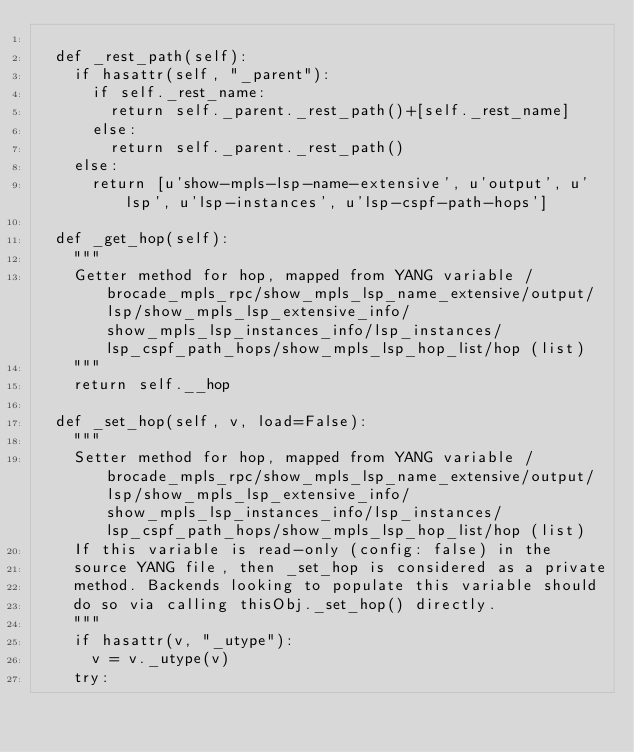<code> <loc_0><loc_0><loc_500><loc_500><_Python_>
  def _rest_path(self):
    if hasattr(self, "_parent"):
      if self._rest_name:
        return self._parent._rest_path()+[self._rest_name]
      else:
        return self._parent._rest_path()
    else:
      return [u'show-mpls-lsp-name-extensive', u'output', u'lsp', u'lsp-instances', u'lsp-cspf-path-hops']

  def _get_hop(self):
    """
    Getter method for hop, mapped from YANG variable /brocade_mpls_rpc/show_mpls_lsp_name_extensive/output/lsp/show_mpls_lsp_extensive_info/show_mpls_lsp_instances_info/lsp_instances/lsp_cspf_path_hops/show_mpls_lsp_hop_list/hop (list)
    """
    return self.__hop
      
  def _set_hop(self, v, load=False):
    """
    Setter method for hop, mapped from YANG variable /brocade_mpls_rpc/show_mpls_lsp_name_extensive/output/lsp/show_mpls_lsp_extensive_info/show_mpls_lsp_instances_info/lsp_instances/lsp_cspf_path_hops/show_mpls_lsp_hop_list/hop (list)
    If this variable is read-only (config: false) in the
    source YANG file, then _set_hop is considered as a private
    method. Backends looking to populate this variable should
    do so via calling thisObj._set_hop() directly.
    """
    if hasattr(v, "_utype"):
      v = v._utype(v)
    try:</code> 